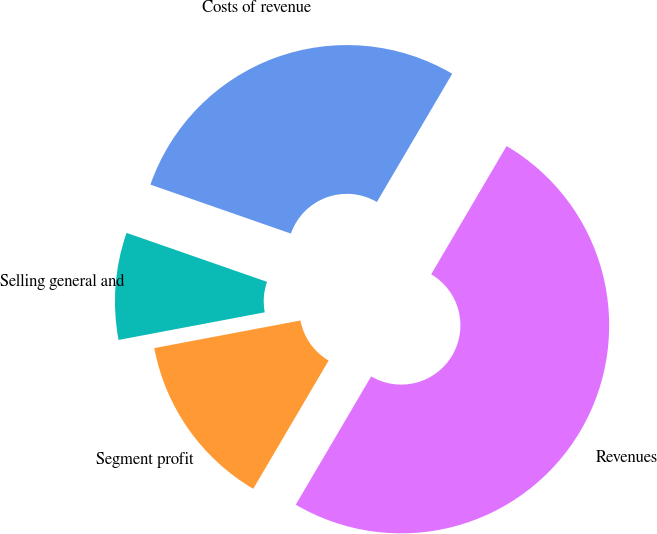Convert chart to OTSL. <chart><loc_0><loc_0><loc_500><loc_500><pie_chart><fcel>Revenues<fcel>Costs of revenue<fcel>Selling general and<fcel>Segment profit<nl><fcel>50.0%<fcel>28.12%<fcel>8.31%<fcel>13.57%<nl></chart> 